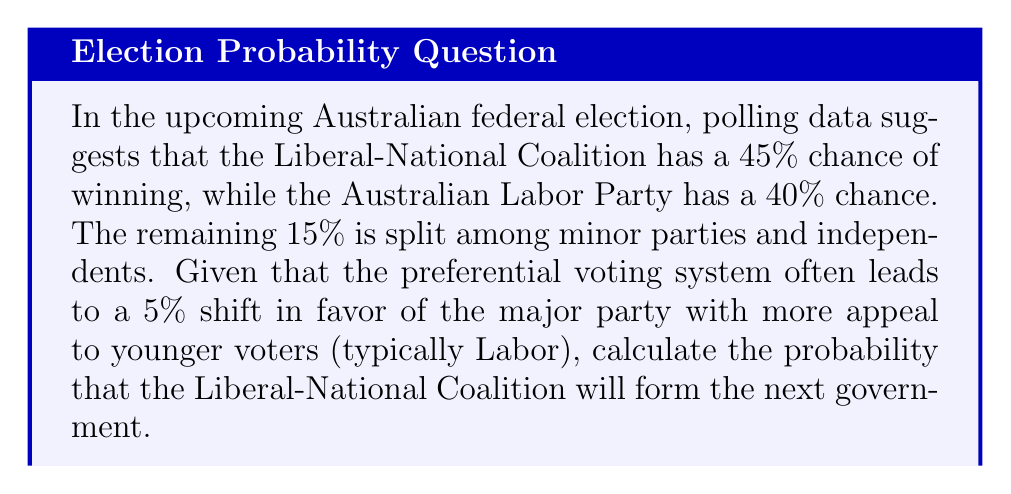Teach me how to tackle this problem. Let's approach this step-by-step:

1) First, we need to account for the preferential voting system. This system typically shifts 5% in favor of the party with more appeal to younger voters, which is usually Labor.

2) We can represent this shift mathematically:

   $$P(\text{Coalition win}) = 0.45 - 0.05 = 0.40$$
   $$P(\text{Labor win}) = 0.40 + 0.05 = 0.45$$

3) Now, we need to normalize these probabilities to account for the fact that only these two major parties can form government. We can do this by dividing each probability by their sum:

   $$P(\text{Coalition win}) = \frac{0.40}{0.40 + 0.45} = \frac{0.40}{0.85}$$

4) To calculate this:

   $$\frac{0.40}{0.85} \approx 0.4706$$

5) Convert to a percentage:

   $$0.4706 \times 100\% \approx 47.06\%$$

Therefore, the probability that the Liberal-National Coalition will form the next government is approximately 47.06%.
Answer: 47.06% 